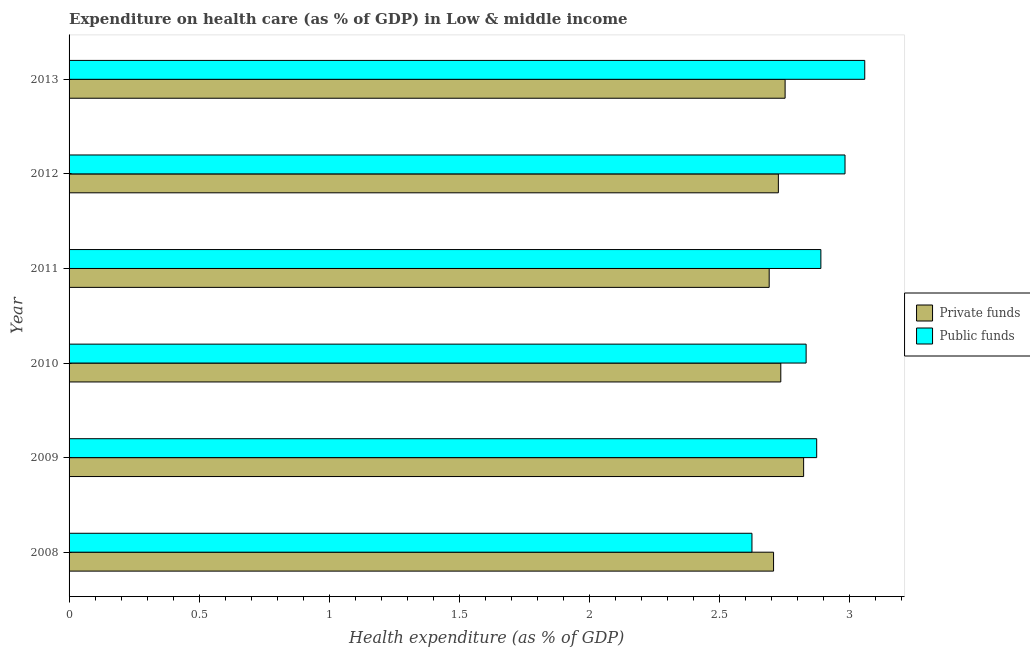How many groups of bars are there?
Your answer should be very brief. 6. Are the number of bars on each tick of the Y-axis equal?
Make the answer very short. Yes. How many bars are there on the 1st tick from the bottom?
Provide a succinct answer. 2. What is the amount of public funds spent in healthcare in 2010?
Offer a very short reply. 2.83. Across all years, what is the maximum amount of private funds spent in healthcare?
Your response must be concise. 2.83. Across all years, what is the minimum amount of public funds spent in healthcare?
Give a very brief answer. 2.63. In which year was the amount of public funds spent in healthcare maximum?
Ensure brevity in your answer.  2013. In which year was the amount of public funds spent in healthcare minimum?
Offer a terse response. 2008. What is the total amount of public funds spent in healthcare in the graph?
Your answer should be very brief. 17.27. What is the difference between the amount of private funds spent in healthcare in 2010 and that in 2011?
Keep it short and to the point. 0.04. What is the difference between the amount of public funds spent in healthcare in 2010 and the amount of private funds spent in healthcare in 2012?
Ensure brevity in your answer.  0.11. What is the average amount of private funds spent in healthcare per year?
Give a very brief answer. 2.74. In the year 2013, what is the difference between the amount of public funds spent in healthcare and amount of private funds spent in healthcare?
Ensure brevity in your answer.  0.31. In how many years, is the amount of public funds spent in healthcare greater than 0.4 %?
Provide a succinct answer. 6. Is the difference between the amount of public funds spent in healthcare in 2009 and 2012 greater than the difference between the amount of private funds spent in healthcare in 2009 and 2012?
Your answer should be compact. No. What is the difference between the highest and the second highest amount of public funds spent in healthcare?
Provide a succinct answer. 0.08. What is the difference between the highest and the lowest amount of public funds spent in healthcare?
Provide a short and direct response. 0.43. In how many years, is the amount of public funds spent in healthcare greater than the average amount of public funds spent in healthcare taken over all years?
Your response must be concise. 3. What does the 1st bar from the top in 2012 represents?
Offer a very short reply. Public funds. What does the 2nd bar from the bottom in 2010 represents?
Make the answer very short. Public funds. How many bars are there?
Give a very brief answer. 12. Are the values on the major ticks of X-axis written in scientific E-notation?
Offer a terse response. No. Does the graph contain any zero values?
Ensure brevity in your answer.  No. What is the title of the graph?
Keep it short and to the point. Expenditure on health care (as % of GDP) in Low & middle income. What is the label or title of the X-axis?
Provide a succinct answer. Health expenditure (as % of GDP). What is the label or title of the Y-axis?
Your answer should be compact. Year. What is the Health expenditure (as % of GDP) in Private funds in 2008?
Offer a terse response. 2.71. What is the Health expenditure (as % of GDP) of Public funds in 2008?
Your answer should be very brief. 2.63. What is the Health expenditure (as % of GDP) of Private funds in 2009?
Make the answer very short. 2.83. What is the Health expenditure (as % of GDP) in Public funds in 2009?
Provide a short and direct response. 2.88. What is the Health expenditure (as % of GDP) in Private funds in 2010?
Make the answer very short. 2.74. What is the Health expenditure (as % of GDP) of Public funds in 2010?
Your answer should be compact. 2.83. What is the Health expenditure (as % of GDP) of Private funds in 2011?
Offer a terse response. 2.69. What is the Health expenditure (as % of GDP) of Public funds in 2011?
Give a very brief answer. 2.89. What is the Health expenditure (as % of GDP) in Private funds in 2012?
Your answer should be very brief. 2.73. What is the Health expenditure (as % of GDP) in Public funds in 2012?
Provide a short and direct response. 2.98. What is the Health expenditure (as % of GDP) of Private funds in 2013?
Provide a succinct answer. 2.75. What is the Health expenditure (as % of GDP) in Public funds in 2013?
Give a very brief answer. 3.06. Across all years, what is the maximum Health expenditure (as % of GDP) of Private funds?
Keep it short and to the point. 2.83. Across all years, what is the maximum Health expenditure (as % of GDP) of Public funds?
Provide a short and direct response. 3.06. Across all years, what is the minimum Health expenditure (as % of GDP) of Private funds?
Make the answer very short. 2.69. Across all years, what is the minimum Health expenditure (as % of GDP) in Public funds?
Provide a succinct answer. 2.63. What is the total Health expenditure (as % of GDP) of Private funds in the graph?
Your answer should be compact. 16.45. What is the total Health expenditure (as % of GDP) in Public funds in the graph?
Your response must be concise. 17.27. What is the difference between the Health expenditure (as % of GDP) of Private funds in 2008 and that in 2009?
Offer a terse response. -0.12. What is the difference between the Health expenditure (as % of GDP) of Public funds in 2008 and that in 2009?
Give a very brief answer. -0.25. What is the difference between the Health expenditure (as % of GDP) in Private funds in 2008 and that in 2010?
Your answer should be compact. -0.03. What is the difference between the Health expenditure (as % of GDP) in Public funds in 2008 and that in 2010?
Your answer should be very brief. -0.21. What is the difference between the Health expenditure (as % of GDP) of Private funds in 2008 and that in 2011?
Provide a succinct answer. 0.02. What is the difference between the Health expenditure (as % of GDP) of Public funds in 2008 and that in 2011?
Your answer should be compact. -0.27. What is the difference between the Health expenditure (as % of GDP) of Private funds in 2008 and that in 2012?
Provide a succinct answer. -0.02. What is the difference between the Health expenditure (as % of GDP) of Public funds in 2008 and that in 2012?
Offer a very short reply. -0.36. What is the difference between the Health expenditure (as % of GDP) of Private funds in 2008 and that in 2013?
Your answer should be very brief. -0.04. What is the difference between the Health expenditure (as % of GDP) of Public funds in 2008 and that in 2013?
Offer a very short reply. -0.43. What is the difference between the Health expenditure (as % of GDP) of Private funds in 2009 and that in 2010?
Provide a succinct answer. 0.09. What is the difference between the Health expenditure (as % of GDP) in Public funds in 2009 and that in 2010?
Provide a short and direct response. 0.04. What is the difference between the Health expenditure (as % of GDP) of Private funds in 2009 and that in 2011?
Make the answer very short. 0.13. What is the difference between the Health expenditure (as % of GDP) in Public funds in 2009 and that in 2011?
Offer a very short reply. -0.02. What is the difference between the Health expenditure (as % of GDP) of Private funds in 2009 and that in 2012?
Make the answer very short. 0.1. What is the difference between the Health expenditure (as % of GDP) in Public funds in 2009 and that in 2012?
Make the answer very short. -0.11. What is the difference between the Health expenditure (as % of GDP) in Private funds in 2009 and that in 2013?
Keep it short and to the point. 0.07. What is the difference between the Health expenditure (as % of GDP) in Public funds in 2009 and that in 2013?
Your response must be concise. -0.18. What is the difference between the Health expenditure (as % of GDP) in Private funds in 2010 and that in 2011?
Your answer should be very brief. 0.04. What is the difference between the Health expenditure (as % of GDP) in Public funds in 2010 and that in 2011?
Your answer should be very brief. -0.06. What is the difference between the Health expenditure (as % of GDP) of Private funds in 2010 and that in 2012?
Make the answer very short. 0.01. What is the difference between the Health expenditure (as % of GDP) in Public funds in 2010 and that in 2012?
Ensure brevity in your answer.  -0.15. What is the difference between the Health expenditure (as % of GDP) in Private funds in 2010 and that in 2013?
Make the answer very short. -0.02. What is the difference between the Health expenditure (as % of GDP) of Public funds in 2010 and that in 2013?
Your answer should be compact. -0.23. What is the difference between the Health expenditure (as % of GDP) in Private funds in 2011 and that in 2012?
Your answer should be very brief. -0.04. What is the difference between the Health expenditure (as % of GDP) in Public funds in 2011 and that in 2012?
Provide a short and direct response. -0.09. What is the difference between the Health expenditure (as % of GDP) in Private funds in 2011 and that in 2013?
Your answer should be compact. -0.06. What is the difference between the Health expenditure (as % of GDP) of Public funds in 2011 and that in 2013?
Provide a succinct answer. -0.17. What is the difference between the Health expenditure (as % of GDP) of Private funds in 2012 and that in 2013?
Your answer should be compact. -0.03. What is the difference between the Health expenditure (as % of GDP) in Public funds in 2012 and that in 2013?
Provide a succinct answer. -0.08. What is the difference between the Health expenditure (as % of GDP) in Private funds in 2008 and the Health expenditure (as % of GDP) in Public funds in 2009?
Keep it short and to the point. -0.17. What is the difference between the Health expenditure (as % of GDP) in Private funds in 2008 and the Health expenditure (as % of GDP) in Public funds in 2010?
Make the answer very short. -0.13. What is the difference between the Health expenditure (as % of GDP) of Private funds in 2008 and the Health expenditure (as % of GDP) of Public funds in 2011?
Provide a succinct answer. -0.18. What is the difference between the Health expenditure (as % of GDP) of Private funds in 2008 and the Health expenditure (as % of GDP) of Public funds in 2012?
Offer a very short reply. -0.27. What is the difference between the Health expenditure (as % of GDP) of Private funds in 2008 and the Health expenditure (as % of GDP) of Public funds in 2013?
Make the answer very short. -0.35. What is the difference between the Health expenditure (as % of GDP) in Private funds in 2009 and the Health expenditure (as % of GDP) in Public funds in 2010?
Ensure brevity in your answer.  -0.01. What is the difference between the Health expenditure (as % of GDP) in Private funds in 2009 and the Health expenditure (as % of GDP) in Public funds in 2011?
Your response must be concise. -0.07. What is the difference between the Health expenditure (as % of GDP) in Private funds in 2009 and the Health expenditure (as % of GDP) in Public funds in 2012?
Your answer should be compact. -0.16. What is the difference between the Health expenditure (as % of GDP) of Private funds in 2009 and the Health expenditure (as % of GDP) of Public funds in 2013?
Your answer should be very brief. -0.24. What is the difference between the Health expenditure (as % of GDP) of Private funds in 2010 and the Health expenditure (as % of GDP) of Public funds in 2011?
Keep it short and to the point. -0.15. What is the difference between the Health expenditure (as % of GDP) in Private funds in 2010 and the Health expenditure (as % of GDP) in Public funds in 2012?
Provide a short and direct response. -0.25. What is the difference between the Health expenditure (as % of GDP) in Private funds in 2010 and the Health expenditure (as % of GDP) in Public funds in 2013?
Your answer should be compact. -0.32. What is the difference between the Health expenditure (as % of GDP) of Private funds in 2011 and the Health expenditure (as % of GDP) of Public funds in 2012?
Ensure brevity in your answer.  -0.29. What is the difference between the Health expenditure (as % of GDP) in Private funds in 2011 and the Health expenditure (as % of GDP) in Public funds in 2013?
Provide a short and direct response. -0.37. What is the difference between the Health expenditure (as % of GDP) in Private funds in 2012 and the Health expenditure (as % of GDP) in Public funds in 2013?
Keep it short and to the point. -0.33. What is the average Health expenditure (as % of GDP) in Private funds per year?
Ensure brevity in your answer.  2.74. What is the average Health expenditure (as % of GDP) of Public funds per year?
Your answer should be compact. 2.88. In the year 2008, what is the difference between the Health expenditure (as % of GDP) of Private funds and Health expenditure (as % of GDP) of Public funds?
Your response must be concise. 0.08. In the year 2009, what is the difference between the Health expenditure (as % of GDP) of Private funds and Health expenditure (as % of GDP) of Public funds?
Ensure brevity in your answer.  -0.05. In the year 2010, what is the difference between the Health expenditure (as % of GDP) in Private funds and Health expenditure (as % of GDP) in Public funds?
Your response must be concise. -0.1. In the year 2011, what is the difference between the Health expenditure (as % of GDP) in Private funds and Health expenditure (as % of GDP) in Public funds?
Give a very brief answer. -0.2. In the year 2012, what is the difference between the Health expenditure (as % of GDP) of Private funds and Health expenditure (as % of GDP) of Public funds?
Your answer should be very brief. -0.26. In the year 2013, what is the difference between the Health expenditure (as % of GDP) of Private funds and Health expenditure (as % of GDP) of Public funds?
Give a very brief answer. -0.31. What is the ratio of the Health expenditure (as % of GDP) in Private funds in 2008 to that in 2009?
Your response must be concise. 0.96. What is the ratio of the Health expenditure (as % of GDP) of Public funds in 2008 to that in 2009?
Your answer should be compact. 0.91. What is the ratio of the Health expenditure (as % of GDP) of Private funds in 2008 to that in 2010?
Give a very brief answer. 0.99. What is the ratio of the Health expenditure (as % of GDP) of Public funds in 2008 to that in 2010?
Your response must be concise. 0.93. What is the ratio of the Health expenditure (as % of GDP) in Public funds in 2008 to that in 2011?
Make the answer very short. 0.91. What is the ratio of the Health expenditure (as % of GDP) of Private funds in 2008 to that in 2012?
Ensure brevity in your answer.  0.99. What is the ratio of the Health expenditure (as % of GDP) in Public funds in 2008 to that in 2012?
Offer a very short reply. 0.88. What is the ratio of the Health expenditure (as % of GDP) in Private funds in 2008 to that in 2013?
Your answer should be very brief. 0.98. What is the ratio of the Health expenditure (as % of GDP) of Public funds in 2008 to that in 2013?
Your answer should be compact. 0.86. What is the ratio of the Health expenditure (as % of GDP) of Private funds in 2009 to that in 2010?
Make the answer very short. 1.03. What is the ratio of the Health expenditure (as % of GDP) of Public funds in 2009 to that in 2010?
Provide a succinct answer. 1.01. What is the ratio of the Health expenditure (as % of GDP) in Private funds in 2009 to that in 2011?
Keep it short and to the point. 1.05. What is the ratio of the Health expenditure (as % of GDP) of Private funds in 2009 to that in 2012?
Offer a very short reply. 1.04. What is the ratio of the Health expenditure (as % of GDP) in Public funds in 2009 to that in 2012?
Keep it short and to the point. 0.96. What is the ratio of the Health expenditure (as % of GDP) of Private funds in 2009 to that in 2013?
Offer a terse response. 1.03. What is the ratio of the Health expenditure (as % of GDP) of Public funds in 2009 to that in 2013?
Provide a short and direct response. 0.94. What is the ratio of the Health expenditure (as % of GDP) in Private funds in 2010 to that in 2011?
Offer a very short reply. 1.02. What is the ratio of the Health expenditure (as % of GDP) in Public funds in 2010 to that in 2011?
Provide a succinct answer. 0.98. What is the ratio of the Health expenditure (as % of GDP) in Public funds in 2010 to that in 2012?
Provide a short and direct response. 0.95. What is the ratio of the Health expenditure (as % of GDP) in Private funds in 2010 to that in 2013?
Make the answer very short. 0.99. What is the ratio of the Health expenditure (as % of GDP) of Public funds in 2010 to that in 2013?
Offer a terse response. 0.93. What is the ratio of the Health expenditure (as % of GDP) in Private funds in 2011 to that in 2012?
Ensure brevity in your answer.  0.99. What is the ratio of the Health expenditure (as % of GDP) of Public funds in 2011 to that in 2012?
Your answer should be compact. 0.97. What is the ratio of the Health expenditure (as % of GDP) in Private funds in 2011 to that in 2013?
Provide a short and direct response. 0.98. What is the ratio of the Health expenditure (as % of GDP) in Public funds in 2011 to that in 2013?
Keep it short and to the point. 0.94. What is the ratio of the Health expenditure (as % of GDP) in Private funds in 2012 to that in 2013?
Keep it short and to the point. 0.99. What is the ratio of the Health expenditure (as % of GDP) in Public funds in 2012 to that in 2013?
Offer a very short reply. 0.98. What is the difference between the highest and the second highest Health expenditure (as % of GDP) of Private funds?
Keep it short and to the point. 0.07. What is the difference between the highest and the second highest Health expenditure (as % of GDP) in Public funds?
Your response must be concise. 0.08. What is the difference between the highest and the lowest Health expenditure (as % of GDP) in Private funds?
Make the answer very short. 0.13. What is the difference between the highest and the lowest Health expenditure (as % of GDP) in Public funds?
Your answer should be compact. 0.43. 